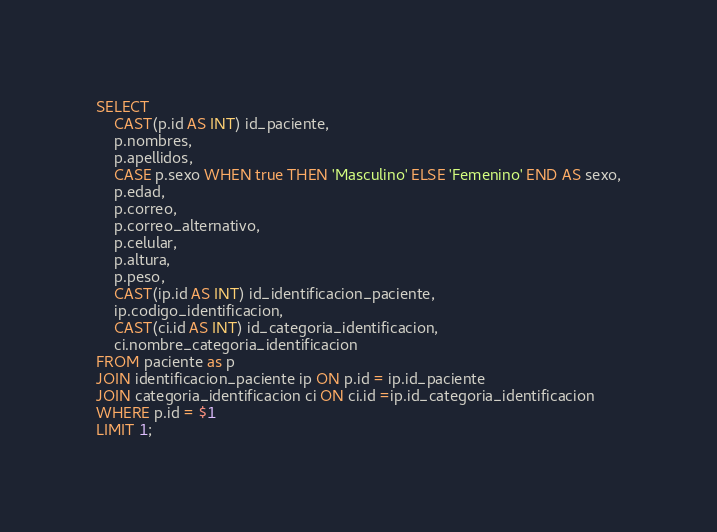Convert code to text. <code><loc_0><loc_0><loc_500><loc_500><_SQL_>SELECT  
	CAST(p.id AS INT) id_paciente,
    p.nombres,
    p.apellidos,
    CASE p.sexo WHEN true THEN 'Masculino' ELSE 'Femenino' END AS sexo,
    p.edad,
    p.correo,
    p.correo_alternativo,
    p.celular,
    p.altura,
    p.peso,
    CAST(ip.id AS INT) id_identificacion_paciente,
    ip.codigo_identificacion,
    CAST(ci.id AS INT) id_categoria_identificacion,
  	ci.nombre_categoria_identificacion
FROM paciente as p
JOIN identificacion_paciente ip ON p.id = ip.id_paciente
JOIN categoria_identificacion ci ON ci.id =ip.id_categoria_identificacion
WHERE p.id = $1
LIMIT 1;</code> 